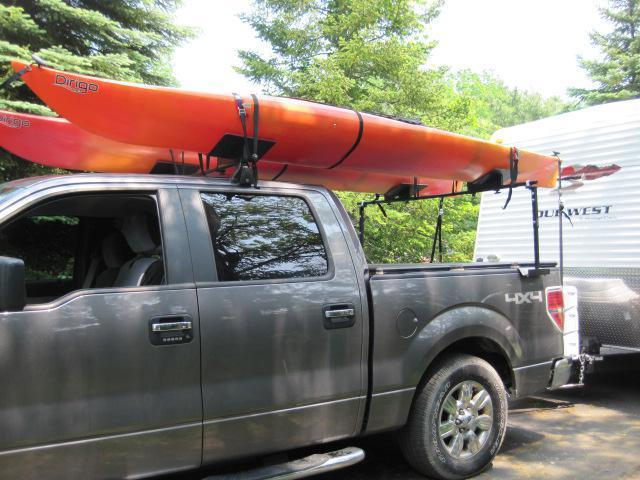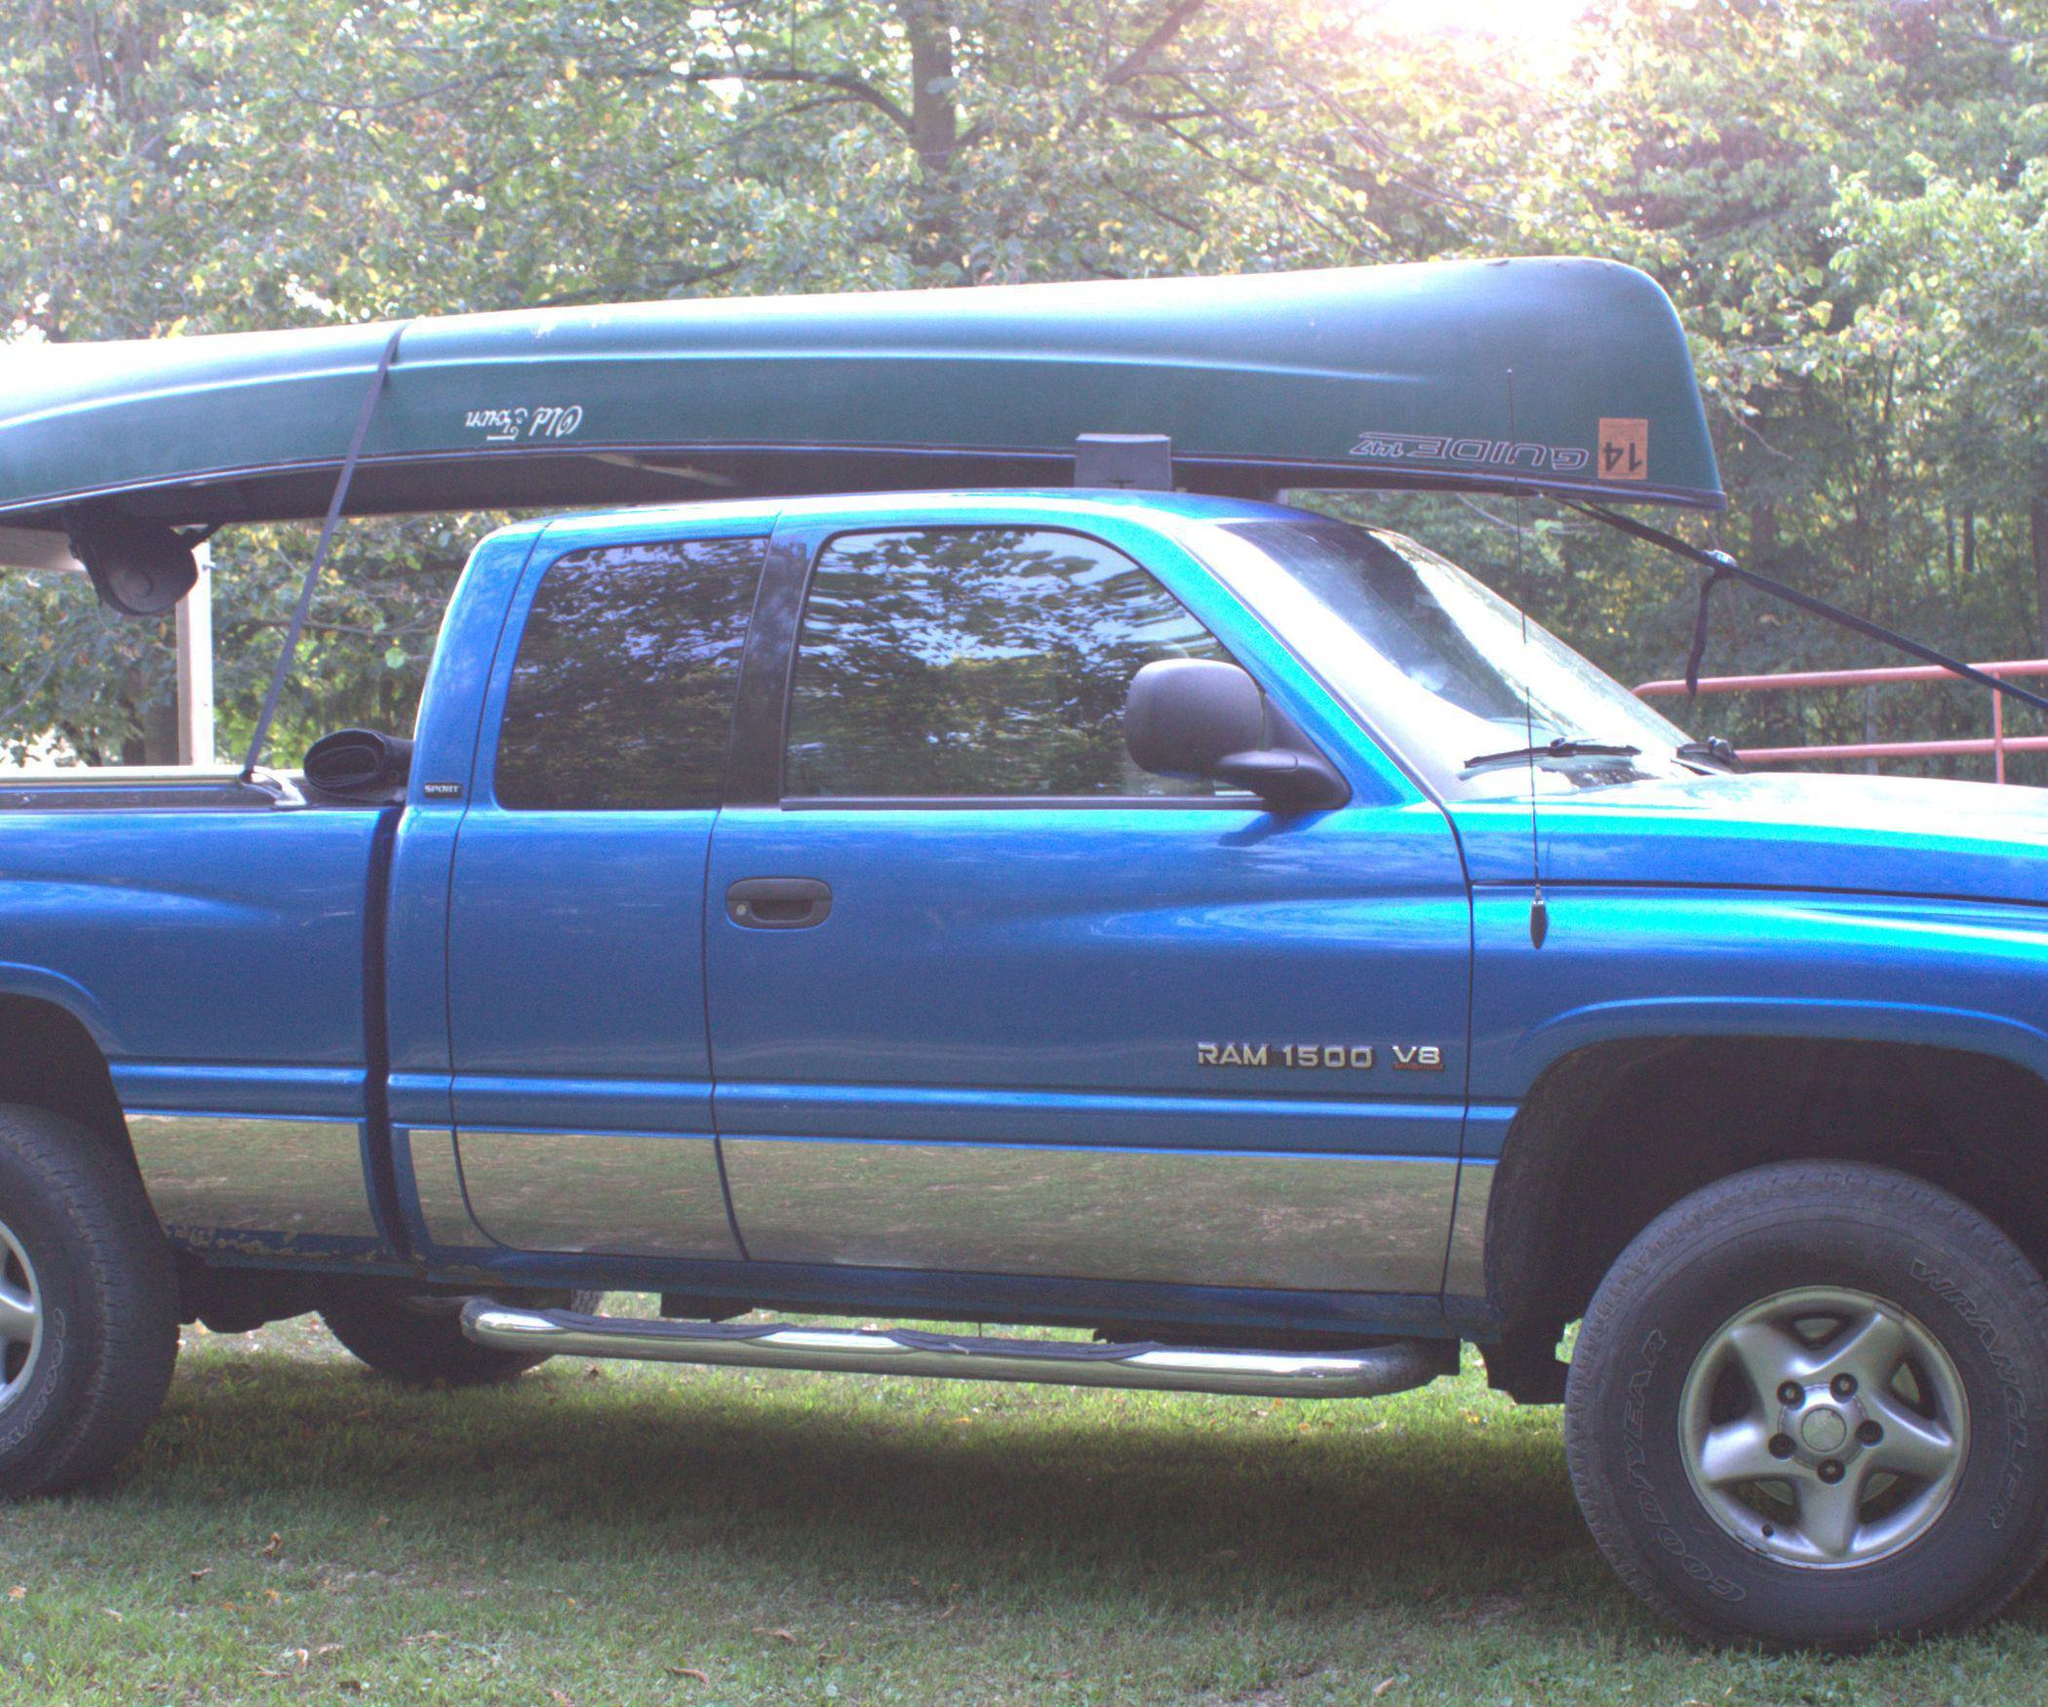The first image is the image on the left, the second image is the image on the right. For the images shown, is this caption "In one image, a canoe is strapped to the top of a blue pickup truck with wide silver trim on the lower panel." true? Answer yes or no. Yes. 